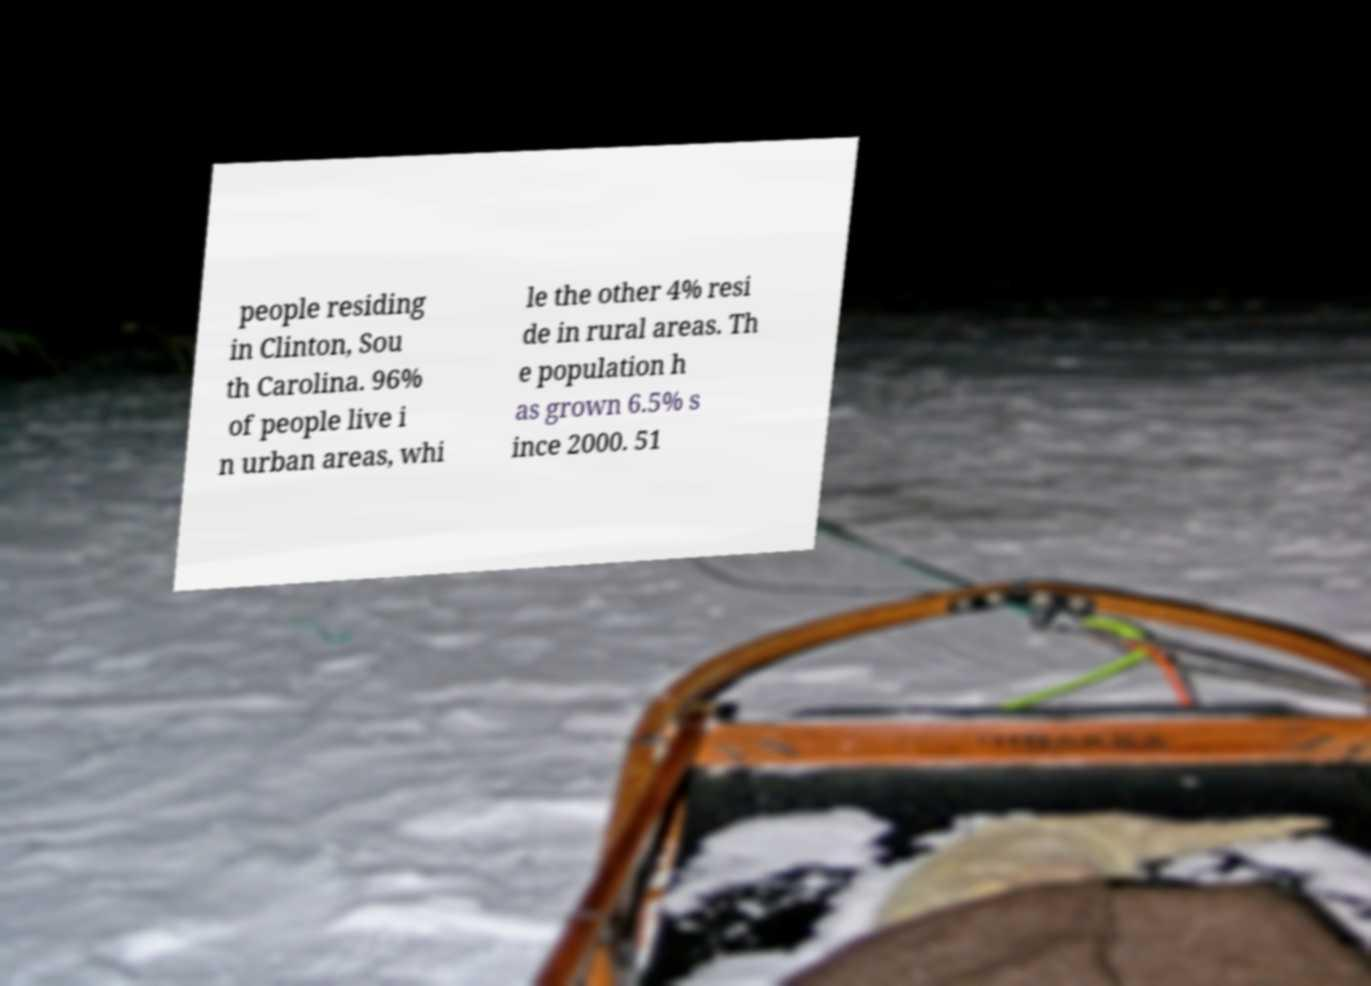Can you accurately transcribe the text from the provided image for me? people residing in Clinton, Sou th Carolina. 96% of people live i n urban areas, whi le the other 4% resi de in rural areas. Th e population h as grown 6.5% s ince 2000. 51 